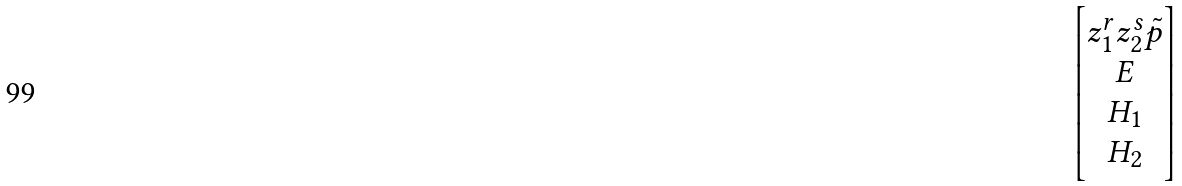<formula> <loc_0><loc_0><loc_500><loc_500>\begin{bmatrix} z _ { 1 } ^ { r } z _ { 2 } ^ { s } \tilde { p } \\ E \\ H _ { 1 } \\ H _ { 2 } \end{bmatrix}</formula> 